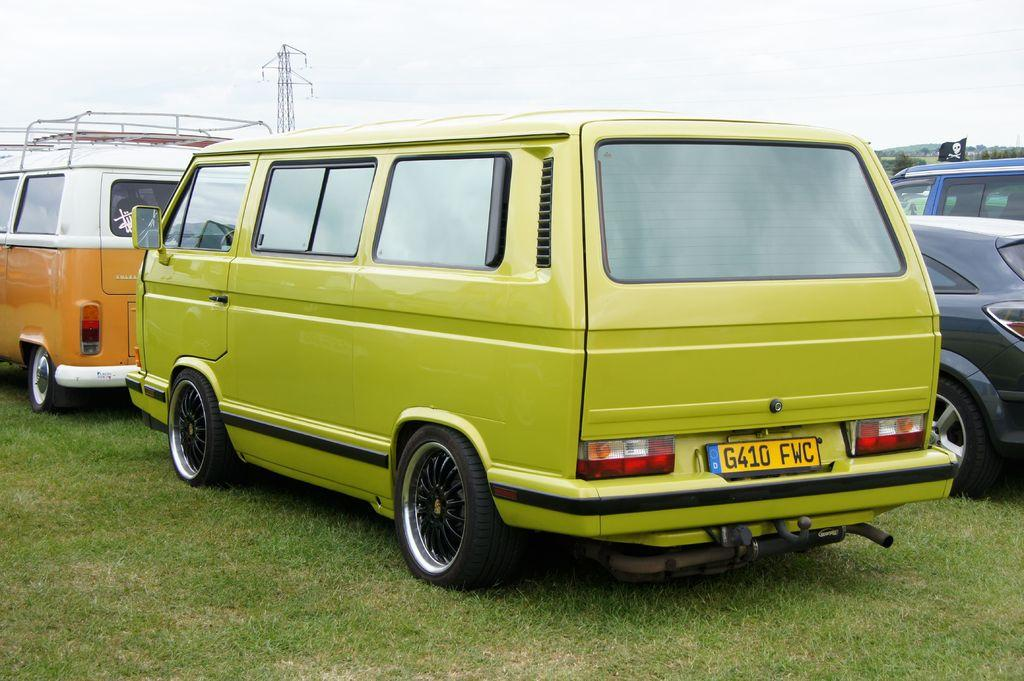<image>
Provide a brief description of the given image. a green VW bus has a yellow license plate saying G410 FWC is sitting behind an orange bus 